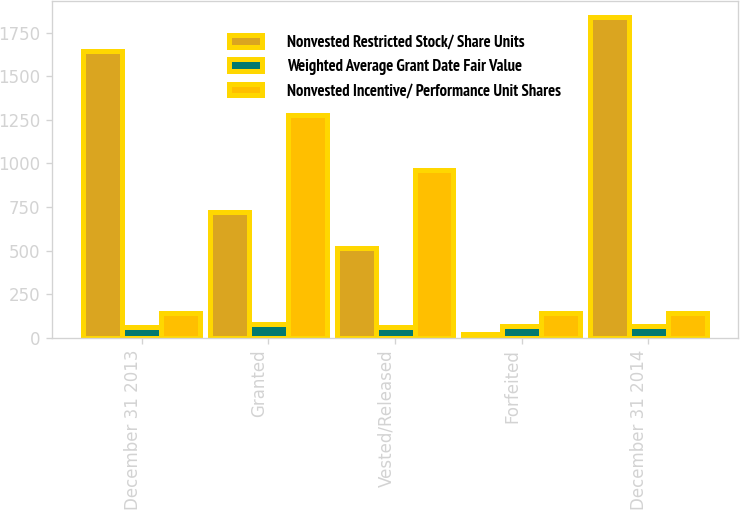<chart> <loc_0><loc_0><loc_500><loc_500><stacked_bar_chart><ecel><fcel>December 31 2013<fcel>Granted<fcel>Vested/Released<fcel>Forfeited<fcel>December 31 2014<nl><fcel>Nonvested Restricted Stock/ Share Units<fcel>1647<fcel>723<fcel>513<fcel>20<fcel>1837<nl><fcel>Weighted Average Grant Date Fair Value<fcel>63.49<fcel>79.9<fcel>63.64<fcel>69.18<fcel>69.84<nl><fcel>Nonvested Incentive/ Performance Unit Shares<fcel>145<fcel>1276<fcel>962<fcel>145<fcel>145<nl></chart> 